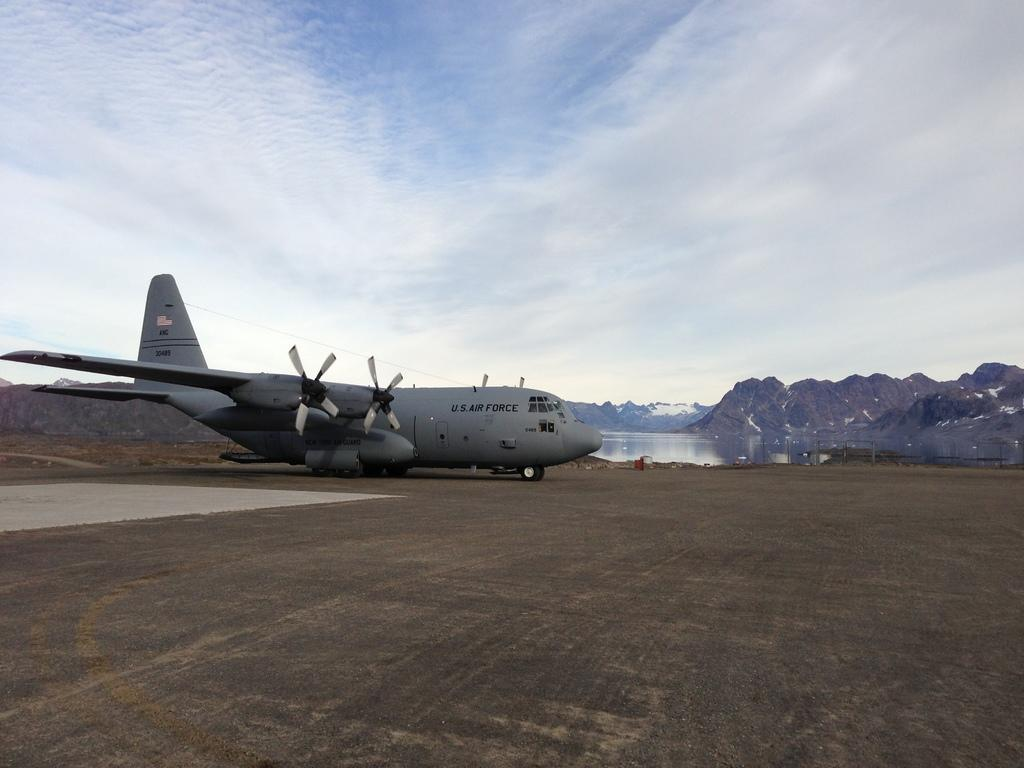What is the main subject of the image? The main subject of the image is an airplane. What is the airplane doing in the image? The airplane is on a path in the image. What can be seen in the background of the image? In the background of the image, there are hills, water, poles, and the sky. How many sisters are visible in the image? There are no sisters present in the image; it features an airplane on a path with a background of hills, water, poles, and the sky. 